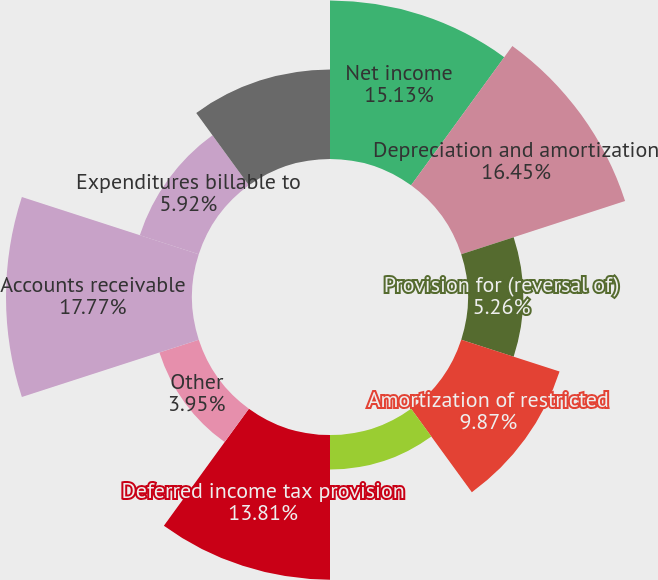<chart> <loc_0><loc_0><loc_500><loc_500><pie_chart><fcel>Net income<fcel>Depreciation and amortization<fcel>Provision for (reversal of)<fcel>Amortization of restricted<fcel>Amortization of bond discounts<fcel>Deferred income tax provision<fcel>Other<fcel>Accounts receivable<fcel>Expenditures billable to<fcel>Prepaid expenses and other<nl><fcel>15.13%<fcel>16.45%<fcel>5.26%<fcel>9.87%<fcel>3.29%<fcel>13.81%<fcel>3.95%<fcel>17.76%<fcel>5.92%<fcel>8.55%<nl></chart> 